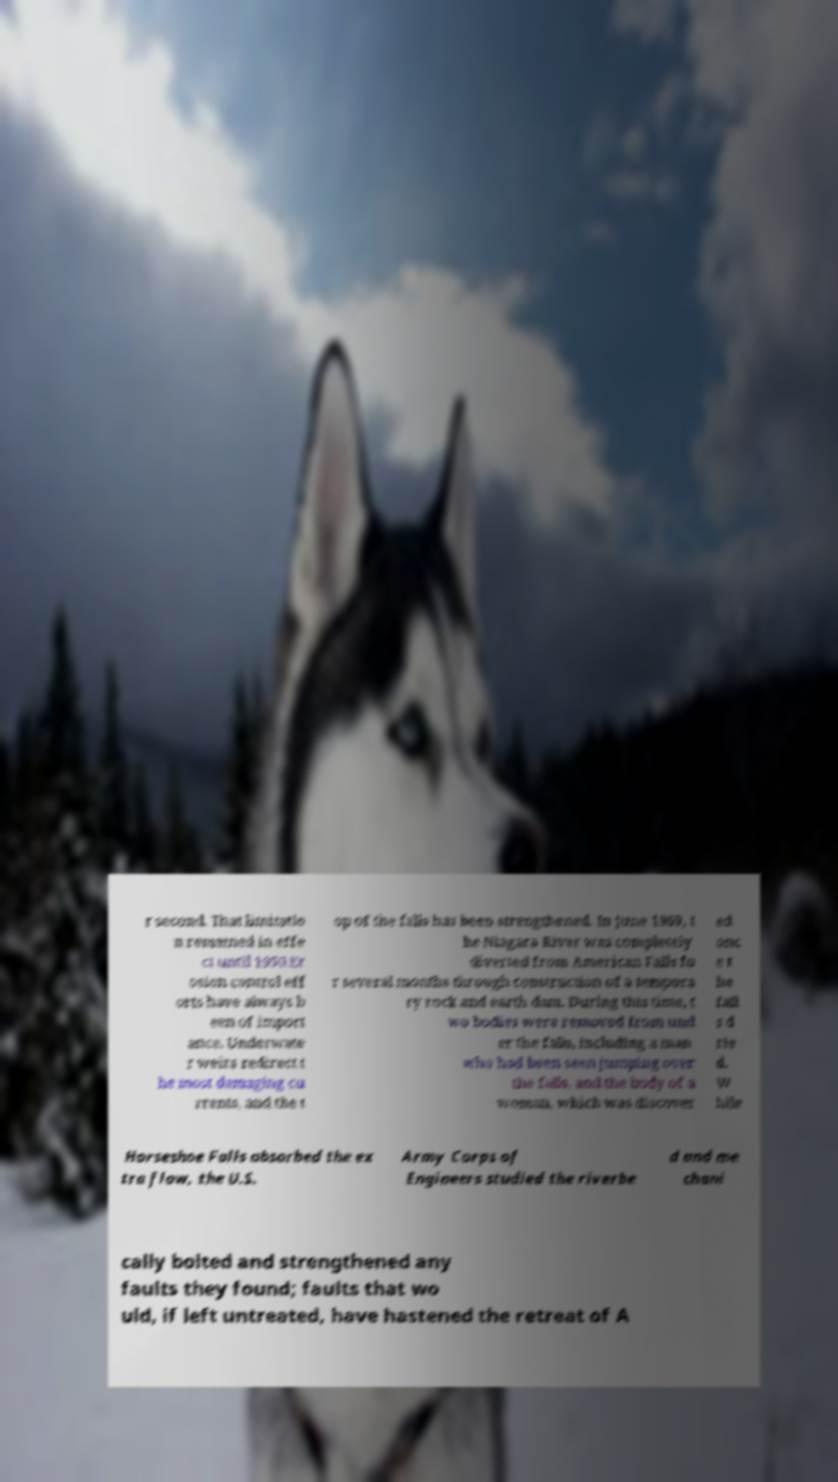There's text embedded in this image that I need extracted. Can you transcribe it verbatim? r second. That limitatio n remained in effe ct until 1950.Er osion control eff orts have always b een of import ance. Underwate r weirs redirect t he most damaging cu rrents, and the t op of the falls has been strengthened. In June 1969, t he Niagara River was completely diverted from American Falls fo r several months through construction of a tempora ry rock and earth dam. During this time, t wo bodies were removed from und er the falls, including a man who had been seen jumping over the falls, and the body of a woman, which was discover ed onc e t he fall s d rie d. W hile Horseshoe Falls absorbed the ex tra flow, the U.S. Army Corps of Engineers studied the riverbe d and me chani cally bolted and strengthened any faults they found; faults that wo uld, if left untreated, have hastened the retreat of A 